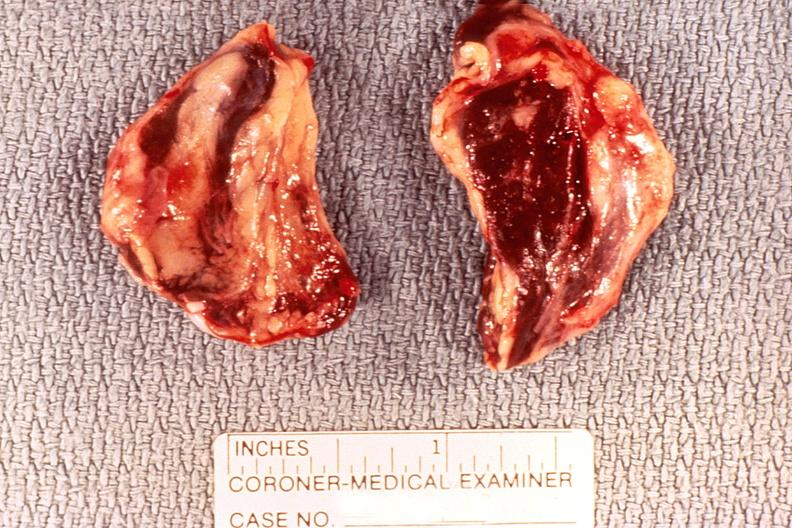where does this belong to?
Answer the question using a single word or phrase. Endocrine system 